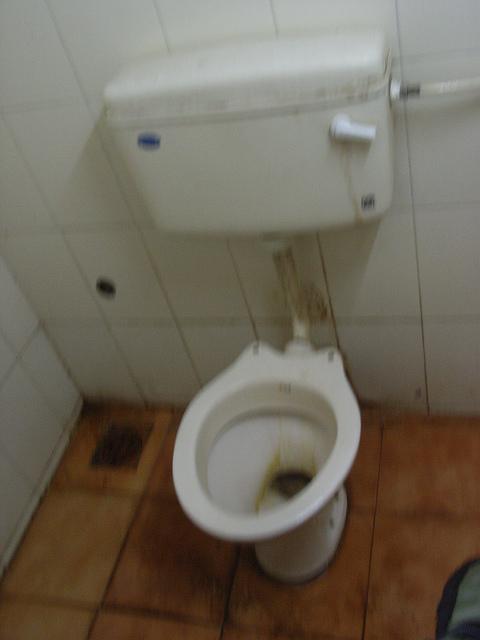Is there an on and off valve for the toilet?
Give a very brief answer. No. What color is the floor?
Write a very short answer. Brown. What color is the walls?
Answer briefly. White. Is the room clean?
Be succinct. No. Where is the toilet seat?
Keep it brief. Gone. How do you flush this toilet?
Concise answer only. Handle. Would you use that toilet?
Keep it brief. No. Is this toilet clean?
Quick response, please. No. Where is the trashcan?
Write a very short answer. No trash can. Does this urinal look clean?
Be succinct. No. What is the shape of the toilet?
Short answer required. Oval. Is this clean?
Keep it brief. No. Is the pictured object a bidet?
Keep it brief. No. Is there a scale in the bathroom?
Short answer required. No. Is this a regular toilet?
Give a very brief answer. No. Will this accommodate a handicap person?
Write a very short answer. No. Why did you not flush this toilet?
Write a very short answer. No water. Is their feces in the toilet?
Short answer required. No. Are the floor and wall tiles the same?
Short answer required. No. Is the toilet clean?
Short answer required. No. 